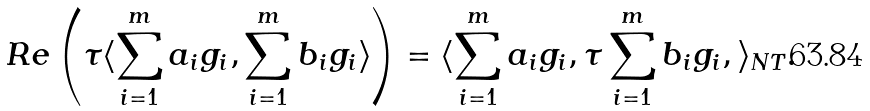<formula> <loc_0><loc_0><loc_500><loc_500>R e \left ( \tau \langle \sum _ { i = 1 } ^ { m } a _ { i } g _ { i } , \sum _ { i = 1 } ^ { m } b _ { i } g _ { i } \rangle \right ) = \langle \sum _ { i = 1 } ^ { m } a _ { i } g _ { i } , \tau \sum _ { i = 1 } ^ { m } b _ { i } g _ { i } , \rangle _ { N T } .</formula> 